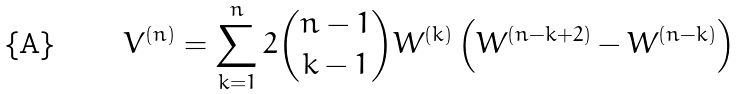<formula> <loc_0><loc_0><loc_500><loc_500>V ^ { ( n ) } = \sum _ { k = 1 } ^ { n } 2 \binom { n - 1 } { k - 1 } W ^ { ( k ) } \left ( W ^ { ( n - k + 2 ) } - W ^ { ( n - k ) } \right ) \,</formula> 